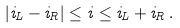Convert formula to latex. <formula><loc_0><loc_0><loc_500><loc_500>| i _ { L } - i _ { R } | \leq i \leq i _ { L } + i _ { R } \, .</formula> 